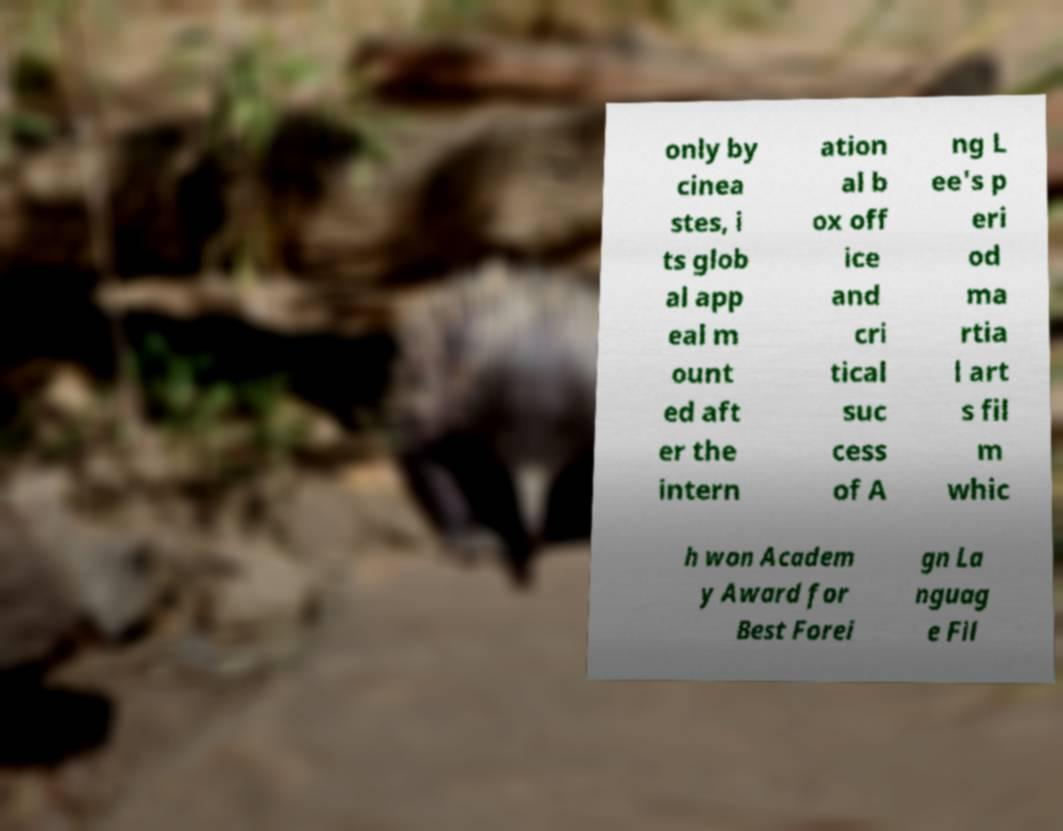Please identify and transcribe the text found in this image. only by cinea stes, i ts glob al app eal m ount ed aft er the intern ation al b ox off ice and cri tical suc cess of A ng L ee's p eri od ma rtia l art s fil m whic h won Academ y Award for Best Forei gn La nguag e Fil 